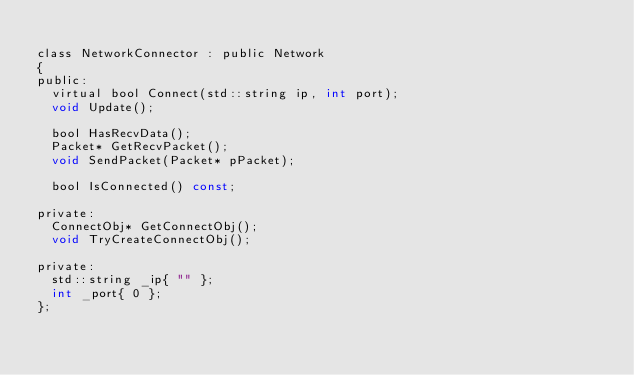Convert code to text. <code><loc_0><loc_0><loc_500><loc_500><_C_>
class NetworkConnector : public Network
{
public:
	virtual bool Connect(std::string ip, int port);
	void Update();

	bool HasRecvData();
	Packet* GetRecvPacket();
	void SendPacket(Packet* pPacket);

	bool IsConnected() const;

private:
	ConnectObj* GetConnectObj();
	void TryCreateConnectObj();

private:
	std::string _ip{ "" };
	int _port{ 0 };
};

</code> 